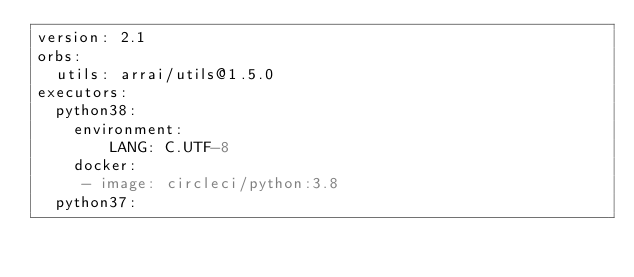<code> <loc_0><loc_0><loc_500><loc_500><_YAML_>version: 2.1
orbs:
  utils: arrai/utils@1.5.0
executors:
  python38:
    environment:
        LANG: C.UTF-8
    docker:
     - image: circleci/python:3.8
  python37:</code> 